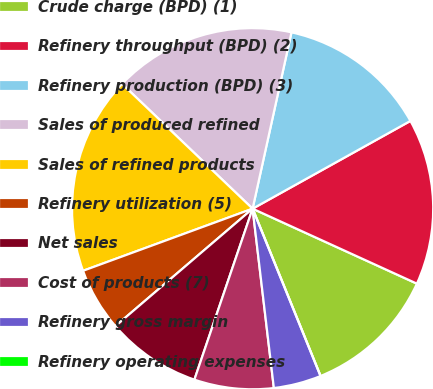Convert chart. <chart><loc_0><loc_0><loc_500><loc_500><pie_chart><fcel>Crude charge (BPD) (1)<fcel>Refinery throughput (BPD) (2)<fcel>Refinery production (BPD) (3)<fcel>Sales of produced refined<fcel>Sales of refined products<fcel>Refinery utilization (5)<fcel>Net sales<fcel>Cost of products (7)<fcel>Refinery gross margin<fcel>Refinery operating expenses<nl><fcel>12.05%<fcel>14.89%<fcel>13.47%<fcel>16.31%<fcel>17.73%<fcel>5.68%<fcel>8.51%<fcel>7.1%<fcel>4.26%<fcel>0.0%<nl></chart> 